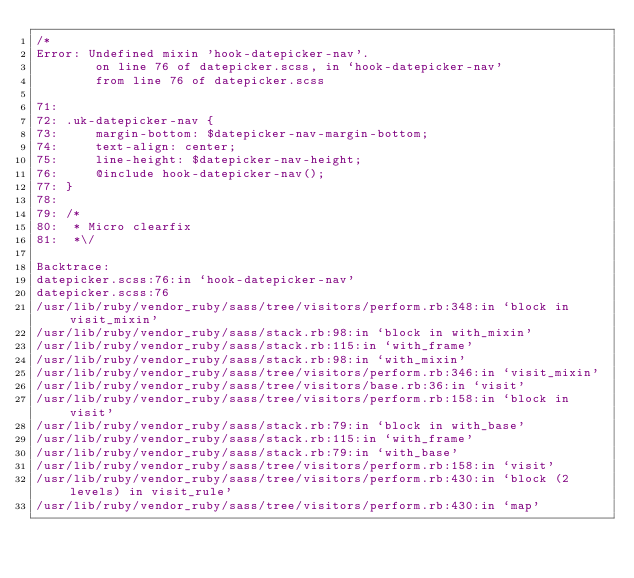Convert code to text. <code><loc_0><loc_0><loc_500><loc_500><_CSS_>/*
Error: Undefined mixin 'hook-datepicker-nav'.
        on line 76 of datepicker.scss, in `hook-datepicker-nav'
        from line 76 of datepicker.scss

71: 
72: .uk-datepicker-nav {
73:     margin-bottom: $datepicker-nav-margin-bottom;
74:     text-align: center;
75:     line-height: $datepicker-nav-height;
76:     @include hook-datepicker-nav();
77: }
78: 
79: /*
80:  * Micro clearfix
81:  *\/

Backtrace:
datepicker.scss:76:in `hook-datepicker-nav'
datepicker.scss:76
/usr/lib/ruby/vendor_ruby/sass/tree/visitors/perform.rb:348:in `block in visit_mixin'
/usr/lib/ruby/vendor_ruby/sass/stack.rb:98:in `block in with_mixin'
/usr/lib/ruby/vendor_ruby/sass/stack.rb:115:in `with_frame'
/usr/lib/ruby/vendor_ruby/sass/stack.rb:98:in `with_mixin'
/usr/lib/ruby/vendor_ruby/sass/tree/visitors/perform.rb:346:in `visit_mixin'
/usr/lib/ruby/vendor_ruby/sass/tree/visitors/base.rb:36:in `visit'
/usr/lib/ruby/vendor_ruby/sass/tree/visitors/perform.rb:158:in `block in visit'
/usr/lib/ruby/vendor_ruby/sass/stack.rb:79:in `block in with_base'
/usr/lib/ruby/vendor_ruby/sass/stack.rb:115:in `with_frame'
/usr/lib/ruby/vendor_ruby/sass/stack.rb:79:in `with_base'
/usr/lib/ruby/vendor_ruby/sass/tree/visitors/perform.rb:158:in `visit'
/usr/lib/ruby/vendor_ruby/sass/tree/visitors/perform.rb:430:in `block (2 levels) in visit_rule'
/usr/lib/ruby/vendor_ruby/sass/tree/visitors/perform.rb:430:in `map'</code> 